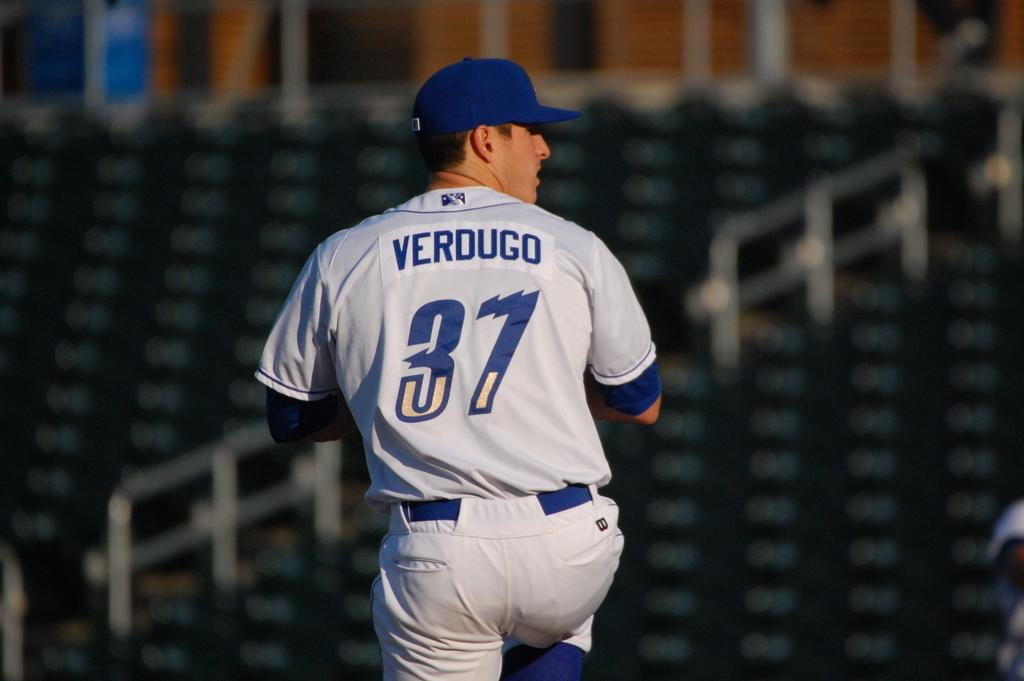<image>
Give a short and clear explanation of the subsequent image. Verdugo number 37 baseball player winds up to throw a ball 